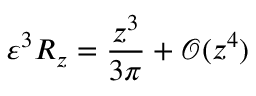Convert formula to latex. <formula><loc_0><loc_0><loc_500><loc_500>\varepsilon ^ { 3 } R _ { z } = \frac { z ^ { 3 } } { 3 \pi } + \mathcal { O } ( z ^ { 4 } )</formula> 